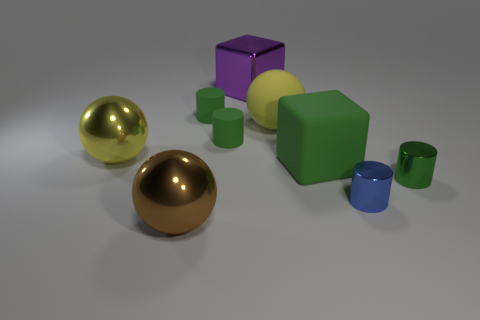Subtract all green cylinders. How many were subtracted if there are1green cylinders left? 2 Subtract all tiny green metal cylinders. How many cylinders are left? 3 Subtract all blue cylinders. How many cylinders are left? 3 Subtract 4 cylinders. How many cylinders are left? 0 Subtract all spheres. How many objects are left? 6 Subtract all big brown shiny spheres. Subtract all large yellow spheres. How many objects are left? 6 Add 1 blocks. How many blocks are left? 3 Add 6 brown shiny objects. How many brown shiny objects exist? 7 Subtract 0 gray cylinders. How many objects are left? 9 Subtract all blue spheres. Subtract all red cylinders. How many spheres are left? 3 